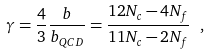Convert formula to latex. <formula><loc_0><loc_0><loc_500><loc_500>\gamma = \frac { 4 } { 3 } \frac { b } { b _ { Q C D } } = \frac { 1 2 N _ { c } - 4 N _ { f } } { 1 1 N _ { c } - 2 N _ { f } } \ ,</formula> 